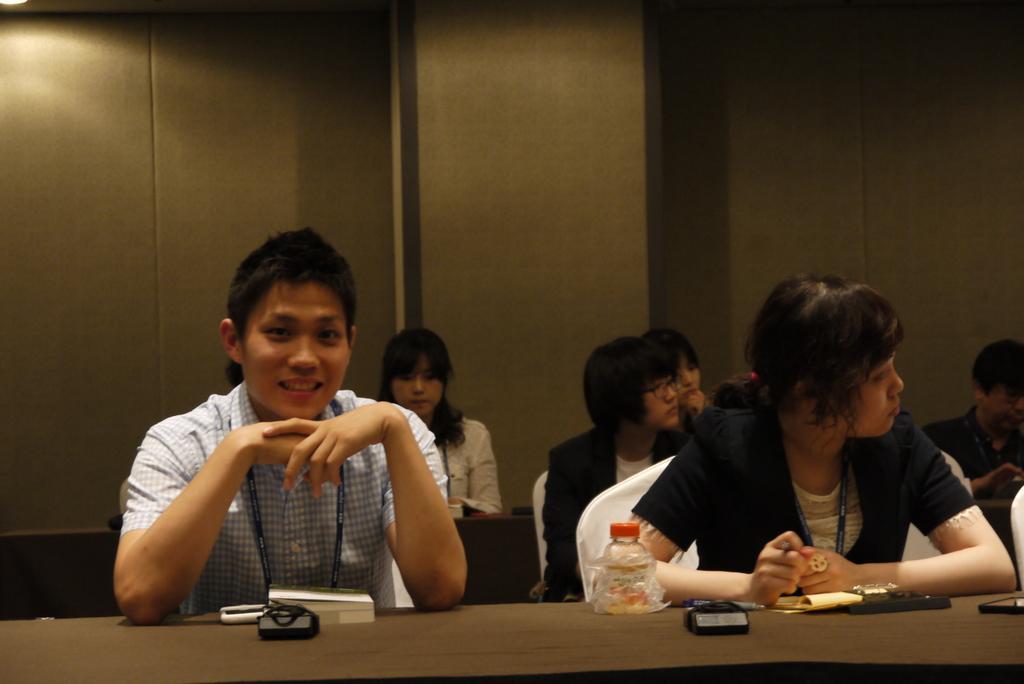Could you give a brief overview of what you see in this image? On the left a man is sitting on the chair and smiling and other people are also sitting on the chairs. 